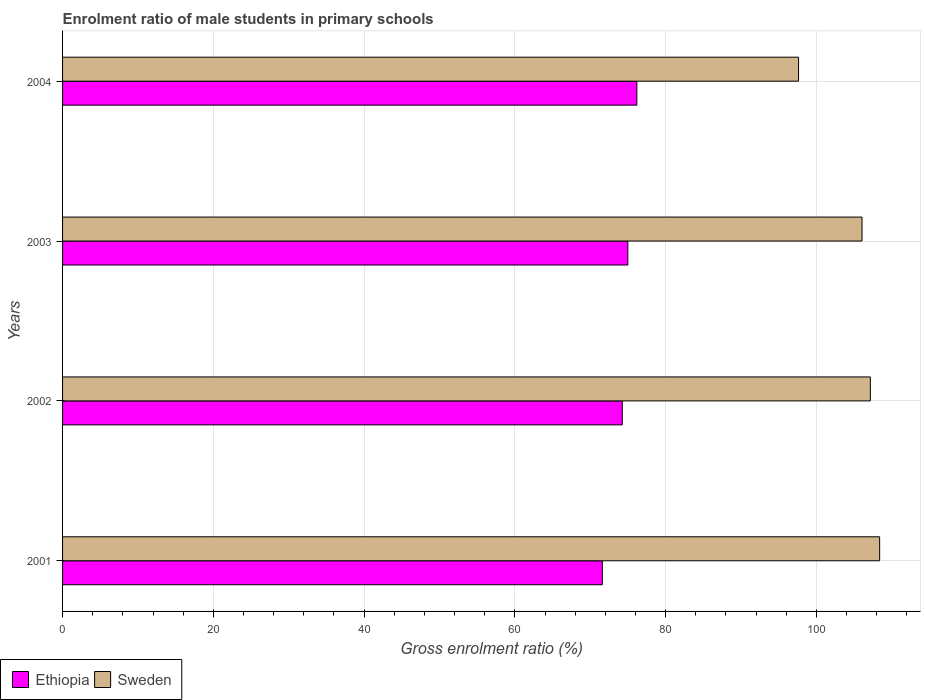How many different coloured bars are there?
Offer a very short reply. 2. How many bars are there on the 4th tick from the top?
Give a very brief answer. 2. What is the label of the 1st group of bars from the top?
Keep it short and to the point. 2004. What is the enrolment ratio of male students in primary schools in Ethiopia in 2002?
Give a very brief answer. 74.24. Across all years, what is the maximum enrolment ratio of male students in primary schools in Ethiopia?
Offer a terse response. 76.18. Across all years, what is the minimum enrolment ratio of male students in primary schools in Ethiopia?
Provide a succinct answer. 71.6. In which year was the enrolment ratio of male students in primary schools in Sweden maximum?
Offer a very short reply. 2001. What is the total enrolment ratio of male students in primary schools in Sweden in the graph?
Your answer should be very brief. 419.2. What is the difference between the enrolment ratio of male students in primary schools in Ethiopia in 2001 and that in 2004?
Give a very brief answer. -4.58. What is the difference between the enrolment ratio of male students in primary schools in Ethiopia in 2003 and the enrolment ratio of male students in primary schools in Sweden in 2002?
Your answer should be very brief. -32.16. What is the average enrolment ratio of male students in primary schools in Ethiopia per year?
Give a very brief answer. 74.25. In the year 2002, what is the difference between the enrolment ratio of male students in primary schools in Ethiopia and enrolment ratio of male students in primary schools in Sweden?
Provide a succinct answer. -32.9. What is the ratio of the enrolment ratio of male students in primary schools in Ethiopia in 2001 to that in 2002?
Offer a very short reply. 0.96. Is the difference between the enrolment ratio of male students in primary schools in Ethiopia in 2003 and 2004 greater than the difference between the enrolment ratio of male students in primary schools in Sweden in 2003 and 2004?
Your response must be concise. No. What is the difference between the highest and the second highest enrolment ratio of male students in primary schools in Sweden?
Your response must be concise. 1.24. What is the difference between the highest and the lowest enrolment ratio of male students in primary schools in Sweden?
Make the answer very short. 10.76. How many bars are there?
Make the answer very short. 8. Are all the bars in the graph horizontal?
Make the answer very short. Yes. How many years are there in the graph?
Offer a terse response. 4. Are the values on the major ticks of X-axis written in scientific E-notation?
Your answer should be compact. No. Does the graph contain any zero values?
Offer a terse response. No. How many legend labels are there?
Provide a succinct answer. 2. How are the legend labels stacked?
Ensure brevity in your answer.  Horizontal. What is the title of the graph?
Provide a short and direct response. Enrolment ratio of male students in primary schools. Does "Brazil" appear as one of the legend labels in the graph?
Offer a very short reply. No. What is the label or title of the Y-axis?
Your answer should be very brief. Years. What is the Gross enrolment ratio (%) in Ethiopia in 2001?
Your answer should be very brief. 71.6. What is the Gross enrolment ratio (%) of Sweden in 2001?
Make the answer very short. 108.38. What is the Gross enrolment ratio (%) in Ethiopia in 2002?
Offer a very short reply. 74.24. What is the Gross enrolment ratio (%) in Sweden in 2002?
Your answer should be very brief. 107.15. What is the Gross enrolment ratio (%) in Ethiopia in 2003?
Provide a short and direct response. 74.98. What is the Gross enrolment ratio (%) in Sweden in 2003?
Provide a succinct answer. 106.05. What is the Gross enrolment ratio (%) in Ethiopia in 2004?
Your answer should be compact. 76.18. What is the Gross enrolment ratio (%) of Sweden in 2004?
Make the answer very short. 97.63. Across all years, what is the maximum Gross enrolment ratio (%) of Ethiopia?
Ensure brevity in your answer.  76.18. Across all years, what is the maximum Gross enrolment ratio (%) of Sweden?
Make the answer very short. 108.38. Across all years, what is the minimum Gross enrolment ratio (%) in Ethiopia?
Your response must be concise. 71.6. Across all years, what is the minimum Gross enrolment ratio (%) of Sweden?
Provide a short and direct response. 97.63. What is the total Gross enrolment ratio (%) of Ethiopia in the graph?
Offer a very short reply. 297. What is the total Gross enrolment ratio (%) of Sweden in the graph?
Your answer should be compact. 419.2. What is the difference between the Gross enrolment ratio (%) of Ethiopia in 2001 and that in 2002?
Provide a succinct answer. -2.64. What is the difference between the Gross enrolment ratio (%) of Sweden in 2001 and that in 2002?
Your answer should be very brief. 1.24. What is the difference between the Gross enrolment ratio (%) in Ethiopia in 2001 and that in 2003?
Your answer should be compact. -3.38. What is the difference between the Gross enrolment ratio (%) in Sweden in 2001 and that in 2003?
Make the answer very short. 2.34. What is the difference between the Gross enrolment ratio (%) in Ethiopia in 2001 and that in 2004?
Your response must be concise. -4.58. What is the difference between the Gross enrolment ratio (%) in Sweden in 2001 and that in 2004?
Offer a very short reply. 10.76. What is the difference between the Gross enrolment ratio (%) in Ethiopia in 2002 and that in 2003?
Provide a succinct answer. -0.74. What is the difference between the Gross enrolment ratio (%) in Sweden in 2002 and that in 2003?
Make the answer very short. 1.1. What is the difference between the Gross enrolment ratio (%) in Ethiopia in 2002 and that in 2004?
Offer a terse response. -1.93. What is the difference between the Gross enrolment ratio (%) in Sweden in 2002 and that in 2004?
Keep it short and to the point. 9.52. What is the difference between the Gross enrolment ratio (%) in Ethiopia in 2003 and that in 2004?
Provide a succinct answer. -1.19. What is the difference between the Gross enrolment ratio (%) of Sweden in 2003 and that in 2004?
Your answer should be compact. 8.42. What is the difference between the Gross enrolment ratio (%) in Ethiopia in 2001 and the Gross enrolment ratio (%) in Sweden in 2002?
Make the answer very short. -35.55. What is the difference between the Gross enrolment ratio (%) in Ethiopia in 2001 and the Gross enrolment ratio (%) in Sweden in 2003?
Keep it short and to the point. -34.45. What is the difference between the Gross enrolment ratio (%) in Ethiopia in 2001 and the Gross enrolment ratio (%) in Sweden in 2004?
Give a very brief answer. -26.03. What is the difference between the Gross enrolment ratio (%) in Ethiopia in 2002 and the Gross enrolment ratio (%) in Sweden in 2003?
Provide a short and direct response. -31.8. What is the difference between the Gross enrolment ratio (%) in Ethiopia in 2002 and the Gross enrolment ratio (%) in Sweden in 2004?
Your answer should be very brief. -23.38. What is the difference between the Gross enrolment ratio (%) in Ethiopia in 2003 and the Gross enrolment ratio (%) in Sweden in 2004?
Your response must be concise. -22.64. What is the average Gross enrolment ratio (%) of Ethiopia per year?
Provide a short and direct response. 74.25. What is the average Gross enrolment ratio (%) of Sweden per year?
Offer a very short reply. 104.8. In the year 2001, what is the difference between the Gross enrolment ratio (%) in Ethiopia and Gross enrolment ratio (%) in Sweden?
Your answer should be compact. -36.78. In the year 2002, what is the difference between the Gross enrolment ratio (%) in Ethiopia and Gross enrolment ratio (%) in Sweden?
Provide a short and direct response. -32.9. In the year 2003, what is the difference between the Gross enrolment ratio (%) of Ethiopia and Gross enrolment ratio (%) of Sweden?
Provide a short and direct response. -31.06. In the year 2004, what is the difference between the Gross enrolment ratio (%) of Ethiopia and Gross enrolment ratio (%) of Sweden?
Your answer should be very brief. -21.45. What is the ratio of the Gross enrolment ratio (%) of Ethiopia in 2001 to that in 2002?
Keep it short and to the point. 0.96. What is the ratio of the Gross enrolment ratio (%) of Sweden in 2001 to that in 2002?
Make the answer very short. 1.01. What is the ratio of the Gross enrolment ratio (%) of Ethiopia in 2001 to that in 2003?
Your answer should be very brief. 0.95. What is the ratio of the Gross enrolment ratio (%) of Sweden in 2001 to that in 2003?
Offer a very short reply. 1.02. What is the ratio of the Gross enrolment ratio (%) in Ethiopia in 2001 to that in 2004?
Your answer should be very brief. 0.94. What is the ratio of the Gross enrolment ratio (%) in Sweden in 2001 to that in 2004?
Offer a very short reply. 1.11. What is the ratio of the Gross enrolment ratio (%) of Ethiopia in 2002 to that in 2003?
Ensure brevity in your answer.  0.99. What is the ratio of the Gross enrolment ratio (%) in Sweden in 2002 to that in 2003?
Your answer should be very brief. 1.01. What is the ratio of the Gross enrolment ratio (%) in Ethiopia in 2002 to that in 2004?
Ensure brevity in your answer.  0.97. What is the ratio of the Gross enrolment ratio (%) of Sweden in 2002 to that in 2004?
Offer a terse response. 1.1. What is the ratio of the Gross enrolment ratio (%) of Ethiopia in 2003 to that in 2004?
Give a very brief answer. 0.98. What is the ratio of the Gross enrolment ratio (%) of Sweden in 2003 to that in 2004?
Offer a terse response. 1.09. What is the difference between the highest and the second highest Gross enrolment ratio (%) in Ethiopia?
Offer a terse response. 1.19. What is the difference between the highest and the second highest Gross enrolment ratio (%) of Sweden?
Provide a succinct answer. 1.24. What is the difference between the highest and the lowest Gross enrolment ratio (%) of Ethiopia?
Provide a short and direct response. 4.58. What is the difference between the highest and the lowest Gross enrolment ratio (%) of Sweden?
Your answer should be compact. 10.76. 